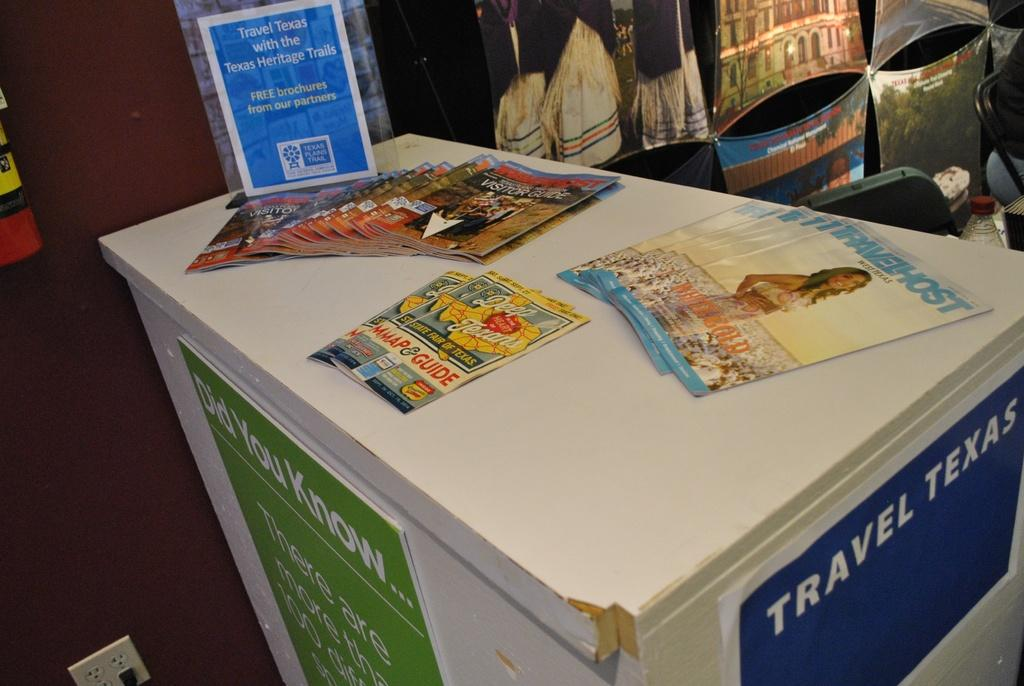<image>
Write a terse but informative summary of the picture. A display for Travel Texas has many different maps and guides 